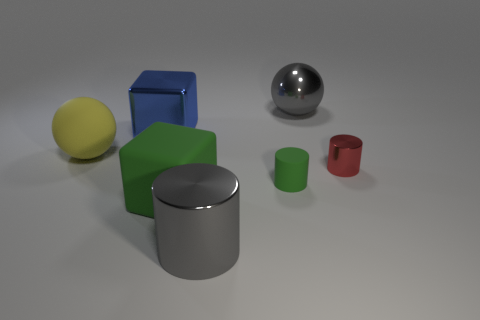Add 1 green rubber cubes. How many objects exist? 8 Subtract all cylinders. How many objects are left? 4 Add 7 metal balls. How many metal balls exist? 8 Subtract 0 blue cylinders. How many objects are left? 7 Subtract all big gray objects. Subtract all large rubber spheres. How many objects are left? 4 Add 2 large gray metallic objects. How many large gray metallic objects are left? 4 